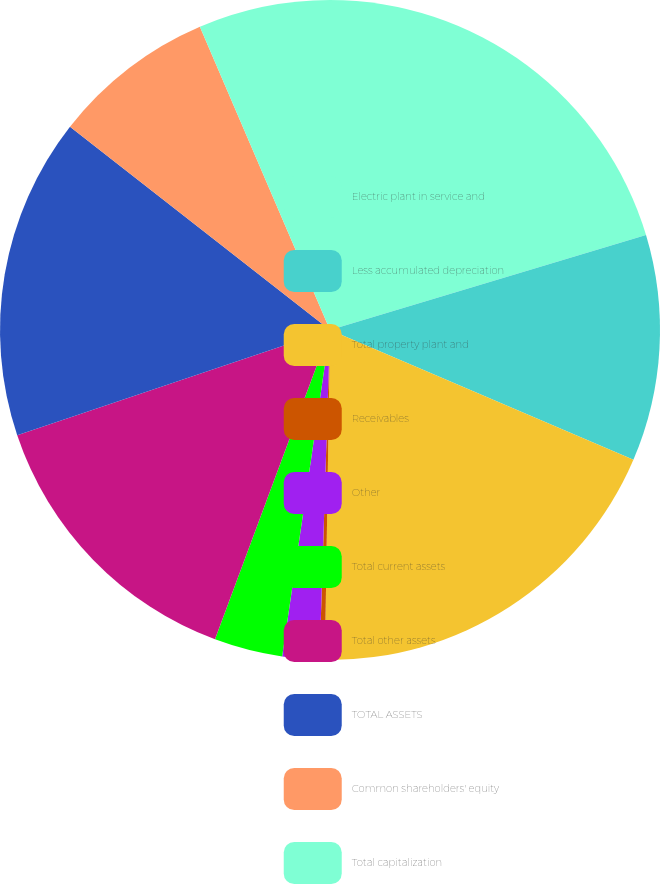Convert chart. <chart><loc_0><loc_0><loc_500><loc_500><pie_chart><fcel>Electric plant in service and<fcel>Less accumulated depreciation<fcel>Total property plant and<fcel>Receivables<fcel>Other<fcel>Total current assets<fcel>Total other assets<fcel>TOTAL ASSETS<fcel>Common shareholders' equity<fcel>Total capitalization<nl><fcel>20.35%<fcel>11.08%<fcel>18.81%<fcel>0.26%<fcel>1.81%<fcel>3.35%<fcel>14.17%<fcel>15.72%<fcel>7.99%<fcel>6.45%<nl></chart> 